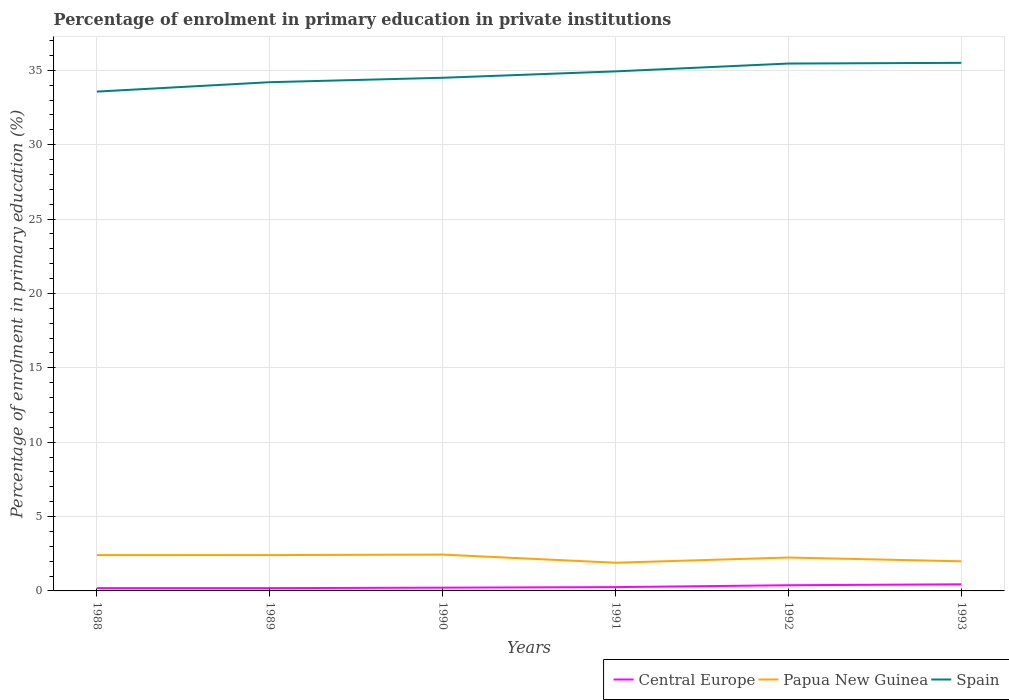How many different coloured lines are there?
Make the answer very short. 3. Does the line corresponding to Spain intersect with the line corresponding to Papua New Guinea?
Your answer should be compact. No. Is the number of lines equal to the number of legend labels?
Make the answer very short. Yes. Across all years, what is the maximum percentage of enrolment in primary education in Papua New Guinea?
Make the answer very short. 1.9. What is the total percentage of enrolment in primary education in Central Europe in the graph?
Ensure brevity in your answer.  -0.03. What is the difference between the highest and the second highest percentage of enrolment in primary education in Papua New Guinea?
Keep it short and to the point. 0.55. How many lines are there?
Provide a succinct answer. 3. Does the graph contain any zero values?
Your answer should be very brief. No. Does the graph contain grids?
Give a very brief answer. Yes. Where does the legend appear in the graph?
Keep it short and to the point. Bottom right. How many legend labels are there?
Give a very brief answer. 3. How are the legend labels stacked?
Keep it short and to the point. Horizontal. What is the title of the graph?
Your answer should be compact. Percentage of enrolment in primary education in private institutions. Does "Liechtenstein" appear as one of the legend labels in the graph?
Make the answer very short. No. What is the label or title of the X-axis?
Offer a terse response. Years. What is the label or title of the Y-axis?
Your answer should be very brief. Percentage of enrolment in primary education (%). What is the Percentage of enrolment in primary education (%) of Central Europe in 1988?
Give a very brief answer. 0.19. What is the Percentage of enrolment in primary education (%) of Papua New Guinea in 1988?
Provide a short and direct response. 2.41. What is the Percentage of enrolment in primary education (%) of Spain in 1988?
Make the answer very short. 33.57. What is the Percentage of enrolment in primary education (%) in Central Europe in 1989?
Offer a very short reply. 0.19. What is the Percentage of enrolment in primary education (%) of Papua New Guinea in 1989?
Your answer should be compact. 2.41. What is the Percentage of enrolment in primary education (%) in Spain in 1989?
Offer a terse response. 34.2. What is the Percentage of enrolment in primary education (%) in Central Europe in 1990?
Keep it short and to the point. 0.22. What is the Percentage of enrolment in primary education (%) in Papua New Guinea in 1990?
Offer a terse response. 2.44. What is the Percentage of enrolment in primary education (%) of Spain in 1990?
Provide a succinct answer. 34.5. What is the Percentage of enrolment in primary education (%) of Central Europe in 1991?
Make the answer very short. 0.26. What is the Percentage of enrolment in primary education (%) of Papua New Guinea in 1991?
Keep it short and to the point. 1.9. What is the Percentage of enrolment in primary education (%) of Spain in 1991?
Offer a terse response. 34.93. What is the Percentage of enrolment in primary education (%) in Central Europe in 1992?
Provide a succinct answer. 0.38. What is the Percentage of enrolment in primary education (%) in Papua New Guinea in 1992?
Offer a very short reply. 2.25. What is the Percentage of enrolment in primary education (%) of Spain in 1992?
Provide a succinct answer. 35.46. What is the Percentage of enrolment in primary education (%) of Central Europe in 1993?
Offer a very short reply. 0.45. What is the Percentage of enrolment in primary education (%) in Papua New Guinea in 1993?
Offer a very short reply. 1.99. What is the Percentage of enrolment in primary education (%) of Spain in 1993?
Make the answer very short. 35.51. Across all years, what is the maximum Percentage of enrolment in primary education (%) in Central Europe?
Your response must be concise. 0.45. Across all years, what is the maximum Percentage of enrolment in primary education (%) in Papua New Guinea?
Your answer should be very brief. 2.44. Across all years, what is the maximum Percentage of enrolment in primary education (%) in Spain?
Your answer should be very brief. 35.51. Across all years, what is the minimum Percentage of enrolment in primary education (%) in Central Europe?
Your response must be concise. 0.19. Across all years, what is the minimum Percentage of enrolment in primary education (%) of Papua New Guinea?
Your answer should be compact. 1.9. Across all years, what is the minimum Percentage of enrolment in primary education (%) of Spain?
Your response must be concise. 33.57. What is the total Percentage of enrolment in primary education (%) in Central Europe in the graph?
Provide a succinct answer. 1.68. What is the total Percentage of enrolment in primary education (%) of Papua New Guinea in the graph?
Your response must be concise. 13.4. What is the total Percentage of enrolment in primary education (%) of Spain in the graph?
Provide a short and direct response. 208.17. What is the difference between the Percentage of enrolment in primary education (%) in Spain in 1988 and that in 1989?
Your answer should be compact. -0.63. What is the difference between the Percentage of enrolment in primary education (%) in Central Europe in 1988 and that in 1990?
Provide a succinct answer. -0.03. What is the difference between the Percentage of enrolment in primary education (%) in Papua New Guinea in 1988 and that in 1990?
Provide a succinct answer. -0.03. What is the difference between the Percentage of enrolment in primary education (%) in Spain in 1988 and that in 1990?
Ensure brevity in your answer.  -0.93. What is the difference between the Percentage of enrolment in primary education (%) in Central Europe in 1988 and that in 1991?
Provide a short and direct response. -0.07. What is the difference between the Percentage of enrolment in primary education (%) of Papua New Guinea in 1988 and that in 1991?
Your answer should be compact. 0.52. What is the difference between the Percentage of enrolment in primary education (%) of Spain in 1988 and that in 1991?
Provide a short and direct response. -1.36. What is the difference between the Percentage of enrolment in primary education (%) of Central Europe in 1988 and that in 1992?
Your response must be concise. -0.19. What is the difference between the Percentage of enrolment in primary education (%) in Papua New Guinea in 1988 and that in 1992?
Make the answer very short. 0.17. What is the difference between the Percentage of enrolment in primary education (%) of Spain in 1988 and that in 1992?
Make the answer very short. -1.89. What is the difference between the Percentage of enrolment in primary education (%) in Central Europe in 1988 and that in 1993?
Offer a terse response. -0.26. What is the difference between the Percentage of enrolment in primary education (%) of Papua New Guinea in 1988 and that in 1993?
Provide a short and direct response. 0.42. What is the difference between the Percentage of enrolment in primary education (%) in Spain in 1988 and that in 1993?
Offer a terse response. -1.93. What is the difference between the Percentage of enrolment in primary education (%) of Central Europe in 1989 and that in 1990?
Offer a very short reply. -0.03. What is the difference between the Percentage of enrolment in primary education (%) of Papua New Guinea in 1989 and that in 1990?
Make the answer very short. -0.03. What is the difference between the Percentage of enrolment in primary education (%) in Spain in 1989 and that in 1990?
Offer a terse response. -0.3. What is the difference between the Percentage of enrolment in primary education (%) of Central Europe in 1989 and that in 1991?
Ensure brevity in your answer.  -0.07. What is the difference between the Percentage of enrolment in primary education (%) in Papua New Guinea in 1989 and that in 1991?
Your answer should be compact. 0.52. What is the difference between the Percentage of enrolment in primary education (%) in Spain in 1989 and that in 1991?
Offer a very short reply. -0.73. What is the difference between the Percentage of enrolment in primary education (%) in Central Europe in 1989 and that in 1992?
Your response must be concise. -0.19. What is the difference between the Percentage of enrolment in primary education (%) in Papua New Guinea in 1989 and that in 1992?
Keep it short and to the point. 0.16. What is the difference between the Percentage of enrolment in primary education (%) of Spain in 1989 and that in 1992?
Keep it short and to the point. -1.25. What is the difference between the Percentage of enrolment in primary education (%) in Central Europe in 1989 and that in 1993?
Your answer should be very brief. -0.26. What is the difference between the Percentage of enrolment in primary education (%) of Papua New Guinea in 1989 and that in 1993?
Keep it short and to the point. 0.42. What is the difference between the Percentage of enrolment in primary education (%) in Spain in 1989 and that in 1993?
Your answer should be very brief. -1.3. What is the difference between the Percentage of enrolment in primary education (%) of Central Europe in 1990 and that in 1991?
Make the answer very short. -0.04. What is the difference between the Percentage of enrolment in primary education (%) of Papua New Guinea in 1990 and that in 1991?
Ensure brevity in your answer.  0.55. What is the difference between the Percentage of enrolment in primary education (%) in Spain in 1990 and that in 1991?
Ensure brevity in your answer.  -0.43. What is the difference between the Percentage of enrolment in primary education (%) of Central Europe in 1990 and that in 1992?
Offer a very short reply. -0.16. What is the difference between the Percentage of enrolment in primary education (%) in Papua New Guinea in 1990 and that in 1992?
Make the answer very short. 0.2. What is the difference between the Percentage of enrolment in primary education (%) of Spain in 1990 and that in 1992?
Ensure brevity in your answer.  -0.96. What is the difference between the Percentage of enrolment in primary education (%) of Central Europe in 1990 and that in 1993?
Offer a very short reply. -0.23. What is the difference between the Percentage of enrolment in primary education (%) in Papua New Guinea in 1990 and that in 1993?
Make the answer very short. 0.45. What is the difference between the Percentage of enrolment in primary education (%) in Spain in 1990 and that in 1993?
Offer a very short reply. -1. What is the difference between the Percentage of enrolment in primary education (%) of Central Europe in 1991 and that in 1992?
Ensure brevity in your answer.  -0.13. What is the difference between the Percentage of enrolment in primary education (%) in Papua New Guinea in 1991 and that in 1992?
Keep it short and to the point. -0.35. What is the difference between the Percentage of enrolment in primary education (%) in Spain in 1991 and that in 1992?
Your answer should be compact. -0.53. What is the difference between the Percentage of enrolment in primary education (%) of Central Europe in 1991 and that in 1993?
Your answer should be very brief. -0.19. What is the difference between the Percentage of enrolment in primary education (%) in Papua New Guinea in 1991 and that in 1993?
Offer a terse response. -0.1. What is the difference between the Percentage of enrolment in primary education (%) in Spain in 1991 and that in 1993?
Your answer should be very brief. -0.57. What is the difference between the Percentage of enrolment in primary education (%) in Central Europe in 1992 and that in 1993?
Your answer should be very brief. -0.06. What is the difference between the Percentage of enrolment in primary education (%) in Papua New Guinea in 1992 and that in 1993?
Offer a very short reply. 0.25. What is the difference between the Percentage of enrolment in primary education (%) of Spain in 1992 and that in 1993?
Your answer should be compact. -0.05. What is the difference between the Percentage of enrolment in primary education (%) of Central Europe in 1988 and the Percentage of enrolment in primary education (%) of Papua New Guinea in 1989?
Provide a succinct answer. -2.22. What is the difference between the Percentage of enrolment in primary education (%) in Central Europe in 1988 and the Percentage of enrolment in primary education (%) in Spain in 1989?
Your answer should be very brief. -34.02. What is the difference between the Percentage of enrolment in primary education (%) of Papua New Guinea in 1988 and the Percentage of enrolment in primary education (%) of Spain in 1989?
Make the answer very short. -31.79. What is the difference between the Percentage of enrolment in primary education (%) in Central Europe in 1988 and the Percentage of enrolment in primary education (%) in Papua New Guinea in 1990?
Offer a terse response. -2.25. What is the difference between the Percentage of enrolment in primary education (%) in Central Europe in 1988 and the Percentage of enrolment in primary education (%) in Spain in 1990?
Your response must be concise. -34.31. What is the difference between the Percentage of enrolment in primary education (%) of Papua New Guinea in 1988 and the Percentage of enrolment in primary education (%) of Spain in 1990?
Keep it short and to the point. -32.09. What is the difference between the Percentage of enrolment in primary education (%) of Central Europe in 1988 and the Percentage of enrolment in primary education (%) of Papua New Guinea in 1991?
Ensure brevity in your answer.  -1.71. What is the difference between the Percentage of enrolment in primary education (%) of Central Europe in 1988 and the Percentage of enrolment in primary education (%) of Spain in 1991?
Offer a very short reply. -34.74. What is the difference between the Percentage of enrolment in primary education (%) of Papua New Guinea in 1988 and the Percentage of enrolment in primary education (%) of Spain in 1991?
Ensure brevity in your answer.  -32.52. What is the difference between the Percentage of enrolment in primary education (%) of Central Europe in 1988 and the Percentage of enrolment in primary education (%) of Papua New Guinea in 1992?
Ensure brevity in your answer.  -2.06. What is the difference between the Percentage of enrolment in primary education (%) in Central Europe in 1988 and the Percentage of enrolment in primary education (%) in Spain in 1992?
Give a very brief answer. -35.27. What is the difference between the Percentage of enrolment in primary education (%) of Papua New Guinea in 1988 and the Percentage of enrolment in primary education (%) of Spain in 1992?
Keep it short and to the point. -33.05. What is the difference between the Percentage of enrolment in primary education (%) in Central Europe in 1988 and the Percentage of enrolment in primary education (%) in Papua New Guinea in 1993?
Offer a very short reply. -1.8. What is the difference between the Percentage of enrolment in primary education (%) of Central Europe in 1988 and the Percentage of enrolment in primary education (%) of Spain in 1993?
Your response must be concise. -35.32. What is the difference between the Percentage of enrolment in primary education (%) in Papua New Guinea in 1988 and the Percentage of enrolment in primary education (%) in Spain in 1993?
Offer a terse response. -33.1. What is the difference between the Percentage of enrolment in primary education (%) of Central Europe in 1989 and the Percentage of enrolment in primary education (%) of Papua New Guinea in 1990?
Give a very brief answer. -2.25. What is the difference between the Percentage of enrolment in primary education (%) of Central Europe in 1989 and the Percentage of enrolment in primary education (%) of Spain in 1990?
Offer a terse response. -34.31. What is the difference between the Percentage of enrolment in primary education (%) in Papua New Guinea in 1989 and the Percentage of enrolment in primary education (%) in Spain in 1990?
Your answer should be compact. -32.09. What is the difference between the Percentage of enrolment in primary education (%) in Central Europe in 1989 and the Percentage of enrolment in primary education (%) in Papua New Guinea in 1991?
Offer a terse response. -1.71. What is the difference between the Percentage of enrolment in primary education (%) in Central Europe in 1989 and the Percentage of enrolment in primary education (%) in Spain in 1991?
Your answer should be very brief. -34.74. What is the difference between the Percentage of enrolment in primary education (%) of Papua New Guinea in 1989 and the Percentage of enrolment in primary education (%) of Spain in 1991?
Provide a short and direct response. -32.52. What is the difference between the Percentage of enrolment in primary education (%) in Central Europe in 1989 and the Percentage of enrolment in primary education (%) in Papua New Guinea in 1992?
Make the answer very short. -2.06. What is the difference between the Percentage of enrolment in primary education (%) of Central Europe in 1989 and the Percentage of enrolment in primary education (%) of Spain in 1992?
Provide a short and direct response. -35.27. What is the difference between the Percentage of enrolment in primary education (%) of Papua New Guinea in 1989 and the Percentage of enrolment in primary education (%) of Spain in 1992?
Make the answer very short. -33.05. What is the difference between the Percentage of enrolment in primary education (%) in Central Europe in 1989 and the Percentage of enrolment in primary education (%) in Papua New Guinea in 1993?
Provide a succinct answer. -1.8. What is the difference between the Percentage of enrolment in primary education (%) of Central Europe in 1989 and the Percentage of enrolment in primary education (%) of Spain in 1993?
Your answer should be compact. -35.32. What is the difference between the Percentage of enrolment in primary education (%) of Papua New Guinea in 1989 and the Percentage of enrolment in primary education (%) of Spain in 1993?
Provide a succinct answer. -33.1. What is the difference between the Percentage of enrolment in primary education (%) in Central Europe in 1990 and the Percentage of enrolment in primary education (%) in Papua New Guinea in 1991?
Give a very brief answer. -1.68. What is the difference between the Percentage of enrolment in primary education (%) of Central Europe in 1990 and the Percentage of enrolment in primary education (%) of Spain in 1991?
Your response must be concise. -34.71. What is the difference between the Percentage of enrolment in primary education (%) in Papua New Guinea in 1990 and the Percentage of enrolment in primary education (%) in Spain in 1991?
Offer a very short reply. -32.49. What is the difference between the Percentage of enrolment in primary education (%) of Central Europe in 1990 and the Percentage of enrolment in primary education (%) of Papua New Guinea in 1992?
Give a very brief answer. -2.03. What is the difference between the Percentage of enrolment in primary education (%) in Central Europe in 1990 and the Percentage of enrolment in primary education (%) in Spain in 1992?
Keep it short and to the point. -35.24. What is the difference between the Percentage of enrolment in primary education (%) of Papua New Guinea in 1990 and the Percentage of enrolment in primary education (%) of Spain in 1992?
Make the answer very short. -33.02. What is the difference between the Percentage of enrolment in primary education (%) of Central Europe in 1990 and the Percentage of enrolment in primary education (%) of Papua New Guinea in 1993?
Offer a very short reply. -1.77. What is the difference between the Percentage of enrolment in primary education (%) of Central Europe in 1990 and the Percentage of enrolment in primary education (%) of Spain in 1993?
Make the answer very short. -35.29. What is the difference between the Percentage of enrolment in primary education (%) of Papua New Guinea in 1990 and the Percentage of enrolment in primary education (%) of Spain in 1993?
Make the answer very short. -33.06. What is the difference between the Percentage of enrolment in primary education (%) of Central Europe in 1991 and the Percentage of enrolment in primary education (%) of Papua New Guinea in 1992?
Ensure brevity in your answer.  -1.99. What is the difference between the Percentage of enrolment in primary education (%) in Central Europe in 1991 and the Percentage of enrolment in primary education (%) in Spain in 1992?
Give a very brief answer. -35.2. What is the difference between the Percentage of enrolment in primary education (%) of Papua New Guinea in 1991 and the Percentage of enrolment in primary education (%) of Spain in 1992?
Offer a terse response. -33.56. What is the difference between the Percentage of enrolment in primary education (%) of Central Europe in 1991 and the Percentage of enrolment in primary education (%) of Papua New Guinea in 1993?
Give a very brief answer. -1.74. What is the difference between the Percentage of enrolment in primary education (%) of Central Europe in 1991 and the Percentage of enrolment in primary education (%) of Spain in 1993?
Your response must be concise. -35.25. What is the difference between the Percentage of enrolment in primary education (%) of Papua New Guinea in 1991 and the Percentage of enrolment in primary education (%) of Spain in 1993?
Offer a terse response. -33.61. What is the difference between the Percentage of enrolment in primary education (%) of Central Europe in 1992 and the Percentage of enrolment in primary education (%) of Papua New Guinea in 1993?
Make the answer very short. -1.61. What is the difference between the Percentage of enrolment in primary education (%) of Central Europe in 1992 and the Percentage of enrolment in primary education (%) of Spain in 1993?
Your answer should be compact. -35.12. What is the difference between the Percentage of enrolment in primary education (%) in Papua New Guinea in 1992 and the Percentage of enrolment in primary education (%) in Spain in 1993?
Ensure brevity in your answer.  -33.26. What is the average Percentage of enrolment in primary education (%) in Central Europe per year?
Make the answer very short. 0.28. What is the average Percentage of enrolment in primary education (%) in Papua New Guinea per year?
Offer a very short reply. 2.23. What is the average Percentage of enrolment in primary education (%) of Spain per year?
Your answer should be compact. 34.7. In the year 1988, what is the difference between the Percentage of enrolment in primary education (%) in Central Europe and Percentage of enrolment in primary education (%) in Papua New Guinea?
Provide a short and direct response. -2.22. In the year 1988, what is the difference between the Percentage of enrolment in primary education (%) in Central Europe and Percentage of enrolment in primary education (%) in Spain?
Provide a succinct answer. -33.38. In the year 1988, what is the difference between the Percentage of enrolment in primary education (%) in Papua New Guinea and Percentage of enrolment in primary education (%) in Spain?
Keep it short and to the point. -31.16. In the year 1989, what is the difference between the Percentage of enrolment in primary education (%) in Central Europe and Percentage of enrolment in primary education (%) in Papua New Guinea?
Keep it short and to the point. -2.22. In the year 1989, what is the difference between the Percentage of enrolment in primary education (%) in Central Europe and Percentage of enrolment in primary education (%) in Spain?
Give a very brief answer. -34.02. In the year 1989, what is the difference between the Percentage of enrolment in primary education (%) of Papua New Guinea and Percentage of enrolment in primary education (%) of Spain?
Keep it short and to the point. -31.79. In the year 1990, what is the difference between the Percentage of enrolment in primary education (%) in Central Europe and Percentage of enrolment in primary education (%) in Papua New Guinea?
Your answer should be very brief. -2.22. In the year 1990, what is the difference between the Percentage of enrolment in primary education (%) in Central Europe and Percentage of enrolment in primary education (%) in Spain?
Keep it short and to the point. -34.28. In the year 1990, what is the difference between the Percentage of enrolment in primary education (%) in Papua New Guinea and Percentage of enrolment in primary education (%) in Spain?
Provide a short and direct response. -32.06. In the year 1991, what is the difference between the Percentage of enrolment in primary education (%) in Central Europe and Percentage of enrolment in primary education (%) in Papua New Guinea?
Ensure brevity in your answer.  -1.64. In the year 1991, what is the difference between the Percentage of enrolment in primary education (%) of Central Europe and Percentage of enrolment in primary education (%) of Spain?
Your answer should be compact. -34.68. In the year 1991, what is the difference between the Percentage of enrolment in primary education (%) in Papua New Guinea and Percentage of enrolment in primary education (%) in Spain?
Keep it short and to the point. -33.04. In the year 1992, what is the difference between the Percentage of enrolment in primary education (%) in Central Europe and Percentage of enrolment in primary education (%) in Papua New Guinea?
Offer a very short reply. -1.86. In the year 1992, what is the difference between the Percentage of enrolment in primary education (%) of Central Europe and Percentage of enrolment in primary education (%) of Spain?
Provide a succinct answer. -35.08. In the year 1992, what is the difference between the Percentage of enrolment in primary education (%) of Papua New Guinea and Percentage of enrolment in primary education (%) of Spain?
Ensure brevity in your answer.  -33.21. In the year 1993, what is the difference between the Percentage of enrolment in primary education (%) in Central Europe and Percentage of enrolment in primary education (%) in Papua New Guinea?
Offer a terse response. -1.55. In the year 1993, what is the difference between the Percentage of enrolment in primary education (%) of Central Europe and Percentage of enrolment in primary education (%) of Spain?
Provide a short and direct response. -35.06. In the year 1993, what is the difference between the Percentage of enrolment in primary education (%) of Papua New Guinea and Percentage of enrolment in primary education (%) of Spain?
Provide a short and direct response. -33.51. What is the ratio of the Percentage of enrolment in primary education (%) of Central Europe in 1988 to that in 1989?
Your answer should be very brief. 1. What is the ratio of the Percentage of enrolment in primary education (%) of Spain in 1988 to that in 1989?
Keep it short and to the point. 0.98. What is the ratio of the Percentage of enrolment in primary education (%) of Central Europe in 1988 to that in 1990?
Ensure brevity in your answer.  0.86. What is the ratio of the Percentage of enrolment in primary education (%) in Papua New Guinea in 1988 to that in 1990?
Keep it short and to the point. 0.99. What is the ratio of the Percentage of enrolment in primary education (%) in Spain in 1988 to that in 1990?
Give a very brief answer. 0.97. What is the ratio of the Percentage of enrolment in primary education (%) in Central Europe in 1988 to that in 1991?
Keep it short and to the point. 0.73. What is the ratio of the Percentage of enrolment in primary education (%) in Papua New Guinea in 1988 to that in 1991?
Offer a very short reply. 1.27. What is the ratio of the Percentage of enrolment in primary education (%) in Spain in 1988 to that in 1991?
Offer a very short reply. 0.96. What is the ratio of the Percentage of enrolment in primary education (%) of Central Europe in 1988 to that in 1992?
Your answer should be compact. 0.49. What is the ratio of the Percentage of enrolment in primary education (%) of Papua New Guinea in 1988 to that in 1992?
Provide a succinct answer. 1.07. What is the ratio of the Percentage of enrolment in primary education (%) in Spain in 1988 to that in 1992?
Offer a very short reply. 0.95. What is the ratio of the Percentage of enrolment in primary education (%) of Central Europe in 1988 to that in 1993?
Ensure brevity in your answer.  0.42. What is the ratio of the Percentage of enrolment in primary education (%) in Papua New Guinea in 1988 to that in 1993?
Keep it short and to the point. 1.21. What is the ratio of the Percentage of enrolment in primary education (%) in Spain in 1988 to that in 1993?
Offer a very short reply. 0.95. What is the ratio of the Percentage of enrolment in primary education (%) of Central Europe in 1989 to that in 1990?
Your response must be concise. 0.86. What is the ratio of the Percentage of enrolment in primary education (%) in Central Europe in 1989 to that in 1991?
Give a very brief answer. 0.73. What is the ratio of the Percentage of enrolment in primary education (%) in Papua New Guinea in 1989 to that in 1991?
Give a very brief answer. 1.27. What is the ratio of the Percentage of enrolment in primary education (%) of Spain in 1989 to that in 1991?
Offer a terse response. 0.98. What is the ratio of the Percentage of enrolment in primary education (%) in Central Europe in 1989 to that in 1992?
Provide a succinct answer. 0.49. What is the ratio of the Percentage of enrolment in primary education (%) of Papua New Guinea in 1989 to that in 1992?
Make the answer very short. 1.07. What is the ratio of the Percentage of enrolment in primary education (%) in Spain in 1989 to that in 1992?
Your response must be concise. 0.96. What is the ratio of the Percentage of enrolment in primary education (%) in Central Europe in 1989 to that in 1993?
Offer a terse response. 0.42. What is the ratio of the Percentage of enrolment in primary education (%) in Papua New Guinea in 1989 to that in 1993?
Offer a very short reply. 1.21. What is the ratio of the Percentage of enrolment in primary education (%) in Spain in 1989 to that in 1993?
Make the answer very short. 0.96. What is the ratio of the Percentage of enrolment in primary education (%) of Central Europe in 1990 to that in 1991?
Your answer should be compact. 0.86. What is the ratio of the Percentage of enrolment in primary education (%) in Papua New Guinea in 1990 to that in 1991?
Your answer should be very brief. 1.29. What is the ratio of the Percentage of enrolment in primary education (%) of Spain in 1990 to that in 1991?
Offer a terse response. 0.99. What is the ratio of the Percentage of enrolment in primary education (%) in Central Europe in 1990 to that in 1992?
Keep it short and to the point. 0.57. What is the ratio of the Percentage of enrolment in primary education (%) of Papua New Guinea in 1990 to that in 1992?
Give a very brief answer. 1.09. What is the ratio of the Percentage of enrolment in primary education (%) of Central Europe in 1990 to that in 1993?
Provide a succinct answer. 0.49. What is the ratio of the Percentage of enrolment in primary education (%) in Papua New Guinea in 1990 to that in 1993?
Your answer should be very brief. 1.23. What is the ratio of the Percentage of enrolment in primary education (%) in Spain in 1990 to that in 1993?
Ensure brevity in your answer.  0.97. What is the ratio of the Percentage of enrolment in primary education (%) of Central Europe in 1991 to that in 1992?
Provide a succinct answer. 0.67. What is the ratio of the Percentage of enrolment in primary education (%) of Papua New Guinea in 1991 to that in 1992?
Offer a terse response. 0.84. What is the ratio of the Percentage of enrolment in primary education (%) of Spain in 1991 to that in 1992?
Make the answer very short. 0.99. What is the ratio of the Percentage of enrolment in primary education (%) in Central Europe in 1991 to that in 1993?
Offer a very short reply. 0.58. What is the ratio of the Percentage of enrolment in primary education (%) of Papua New Guinea in 1991 to that in 1993?
Ensure brevity in your answer.  0.95. What is the ratio of the Percentage of enrolment in primary education (%) of Spain in 1991 to that in 1993?
Provide a short and direct response. 0.98. What is the ratio of the Percentage of enrolment in primary education (%) in Central Europe in 1992 to that in 1993?
Give a very brief answer. 0.86. What is the ratio of the Percentage of enrolment in primary education (%) in Papua New Guinea in 1992 to that in 1993?
Offer a terse response. 1.13. What is the ratio of the Percentage of enrolment in primary education (%) in Spain in 1992 to that in 1993?
Your answer should be very brief. 1. What is the difference between the highest and the second highest Percentage of enrolment in primary education (%) of Central Europe?
Ensure brevity in your answer.  0.06. What is the difference between the highest and the second highest Percentage of enrolment in primary education (%) in Papua New Guinea?
Offer a terse response. 0.03. What is the difference between the highest and the second highest Percentage of enrolment in primary education (%) in Spain?
Ensure brevity in your answer.  0.05. What is the difference between the highest and the lowest Percentage of enrolment in primary education (%) in Central Europe?
Provide a succinct answer. 0.26. What is the difference between the highest and the lowest Percentage of enrolment in primary education (%) in Papua New Guinea?
Your answer should be very brief. 0.55. What is the difference between the highest and the lowest Percentage of enrolment in primary education (%) in Spain?
Offer a terse response. 1.93. 